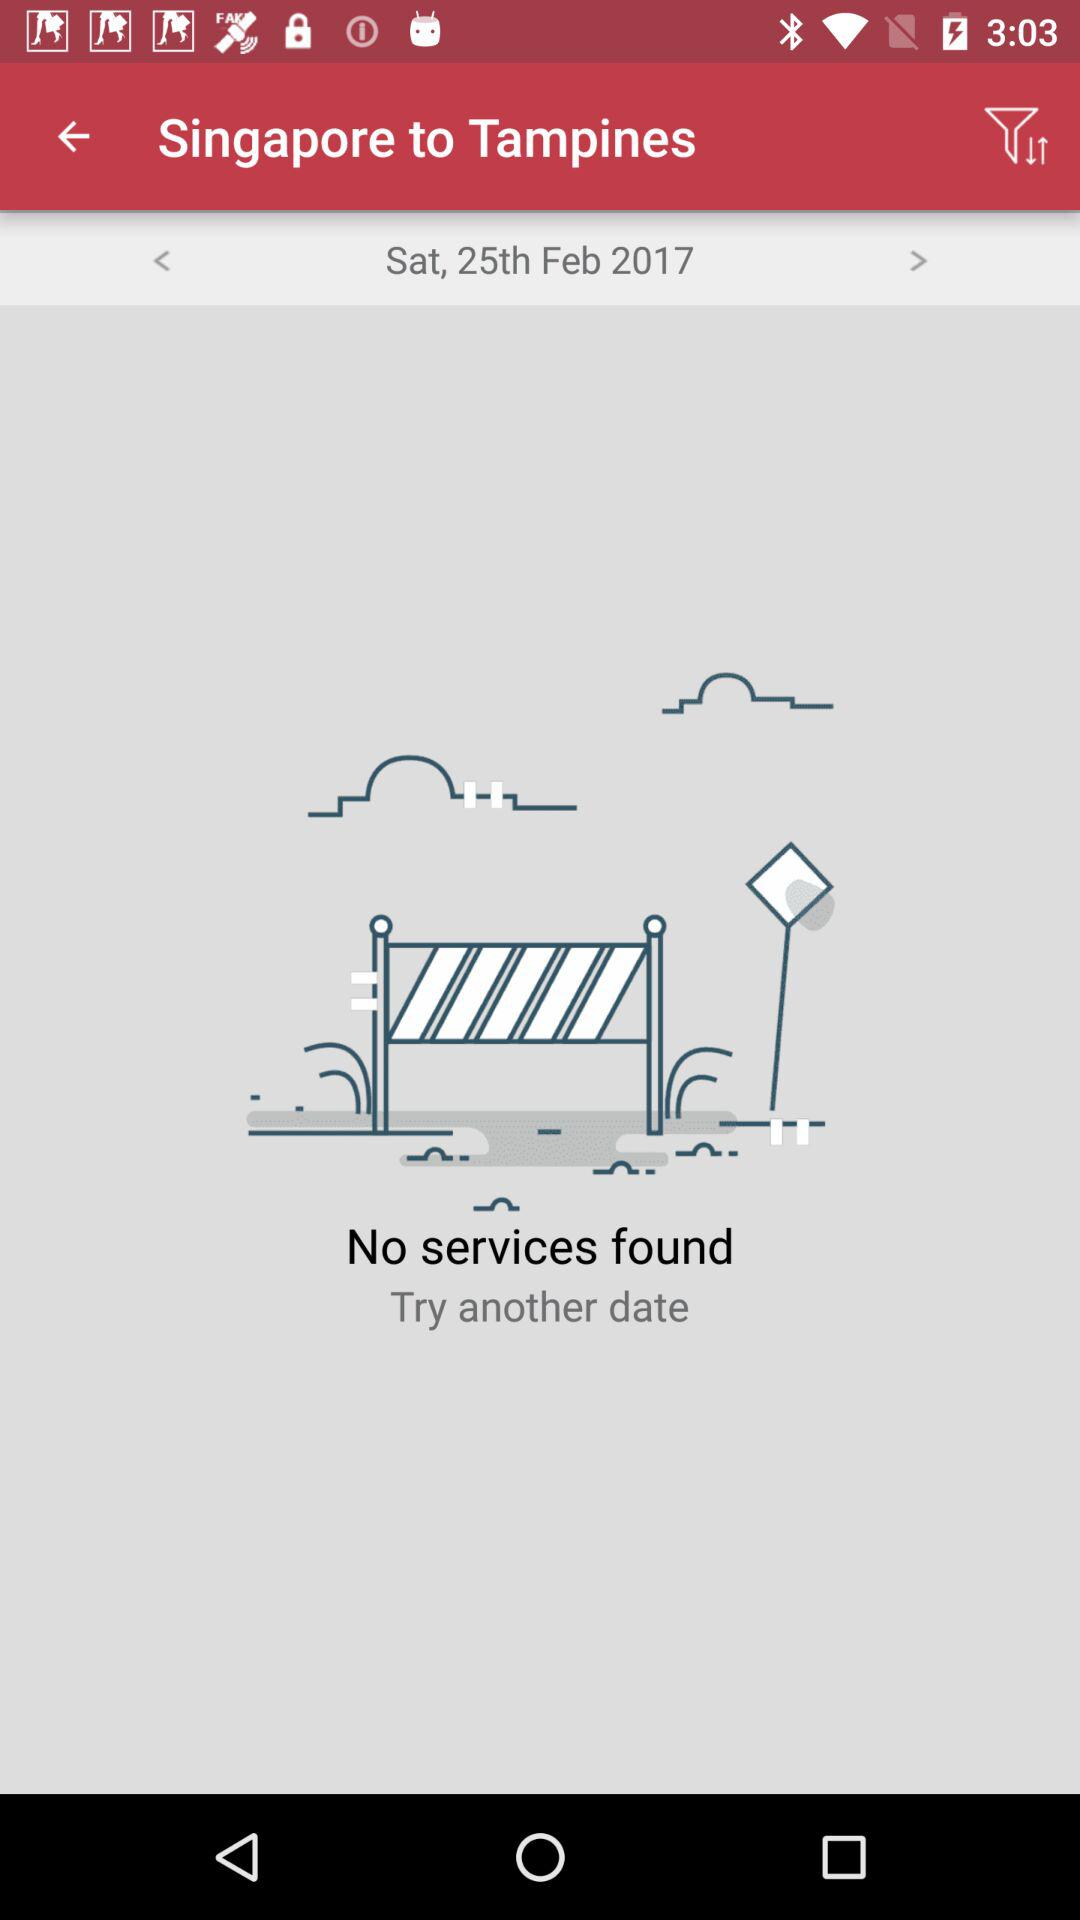What is the current location? The current location is Singapore. 